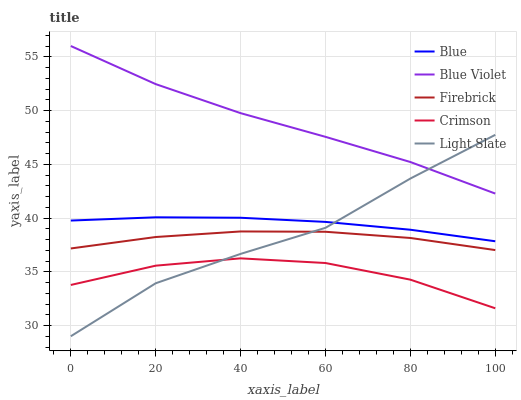Does Crimson have the minimum area under the curve?
Answer yes or no. Yes. Does Blue Violet have the maximum area under the curve?
Answer yes or no. Yes. Does Firebrick have the minimum area under the curve?
Answer yes or no. No. Does Firebrick have the maximum area under the curve?
Answer yes or no. No. Is Blue the smoothest?
Answer yes or no. Yes. Is Light Slate the roughest?
Answer yes or no. Yes. Is Crimson the smoothest?
Answer yes or no. No. Is Crimson the roughest?
Answer yes or no. No. Does Crimson have the lowest value?
Answer yes or no. No. Does Blue Violet have the highest value?
Answer yes or no. Yes. Does Firebrick have the highest value?
Answer yes or no. No. Is Crimson less than Blue?
Answer yes or no. Yes. Is Firebrick greater than Crimson?
Answer yes or no. Yes. Does Light Slate intersect Firebrick?
Answer yes or no. Yes. Is Light Slate less than Firebrick?
Answer yes or no. No. Is Light Slate greater than Firebrick?
Answer yes or no. No. Does Crimson intersect Blue?
Answer yes or no. No. 